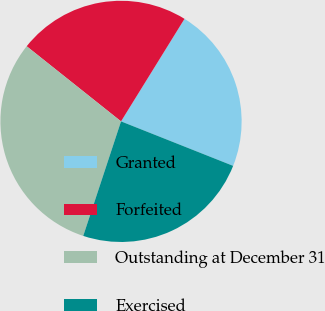Convert chart. <chart><loc_0><loc_0><loc_500><loc_500><pie_chart><fcel>Granted<fcel>Forfeited<fcel>Outstanding at December 31<fcel>Exercised<nl><fcel>22.19%<fcel>23.12%<fcel>30.63%<fcel>24.06%<nl></chart> 